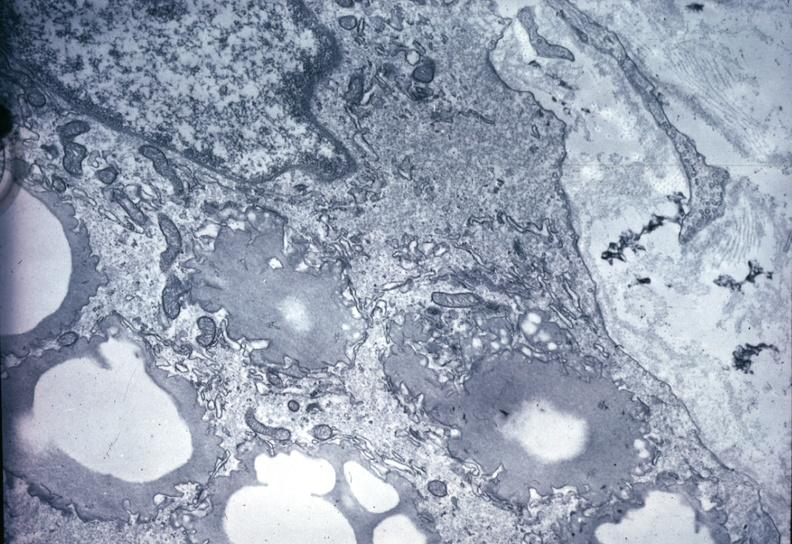what is present?
Answer the question using a single word or phrase. Vasculature 